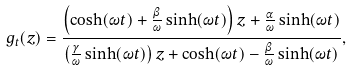<formula> <loc_0><loc_0><loc_500><loc_500>g _ { t } ( z ) = \frac { \left ( \cosh ( \omega t ) + \frac { \beta } { \omega } \sinh ( \omega t ) \right ) z + \frac { \alpha } { \omega } \sinh ( \omega t ) } { \left ( \frac { \gamma } { \omega } \sinh ( \omega t ) \right ) z + \cosh ( \omega t ) - \frac { \beta } { \omega } \sinh ( \omega t ) } ,</formula> 